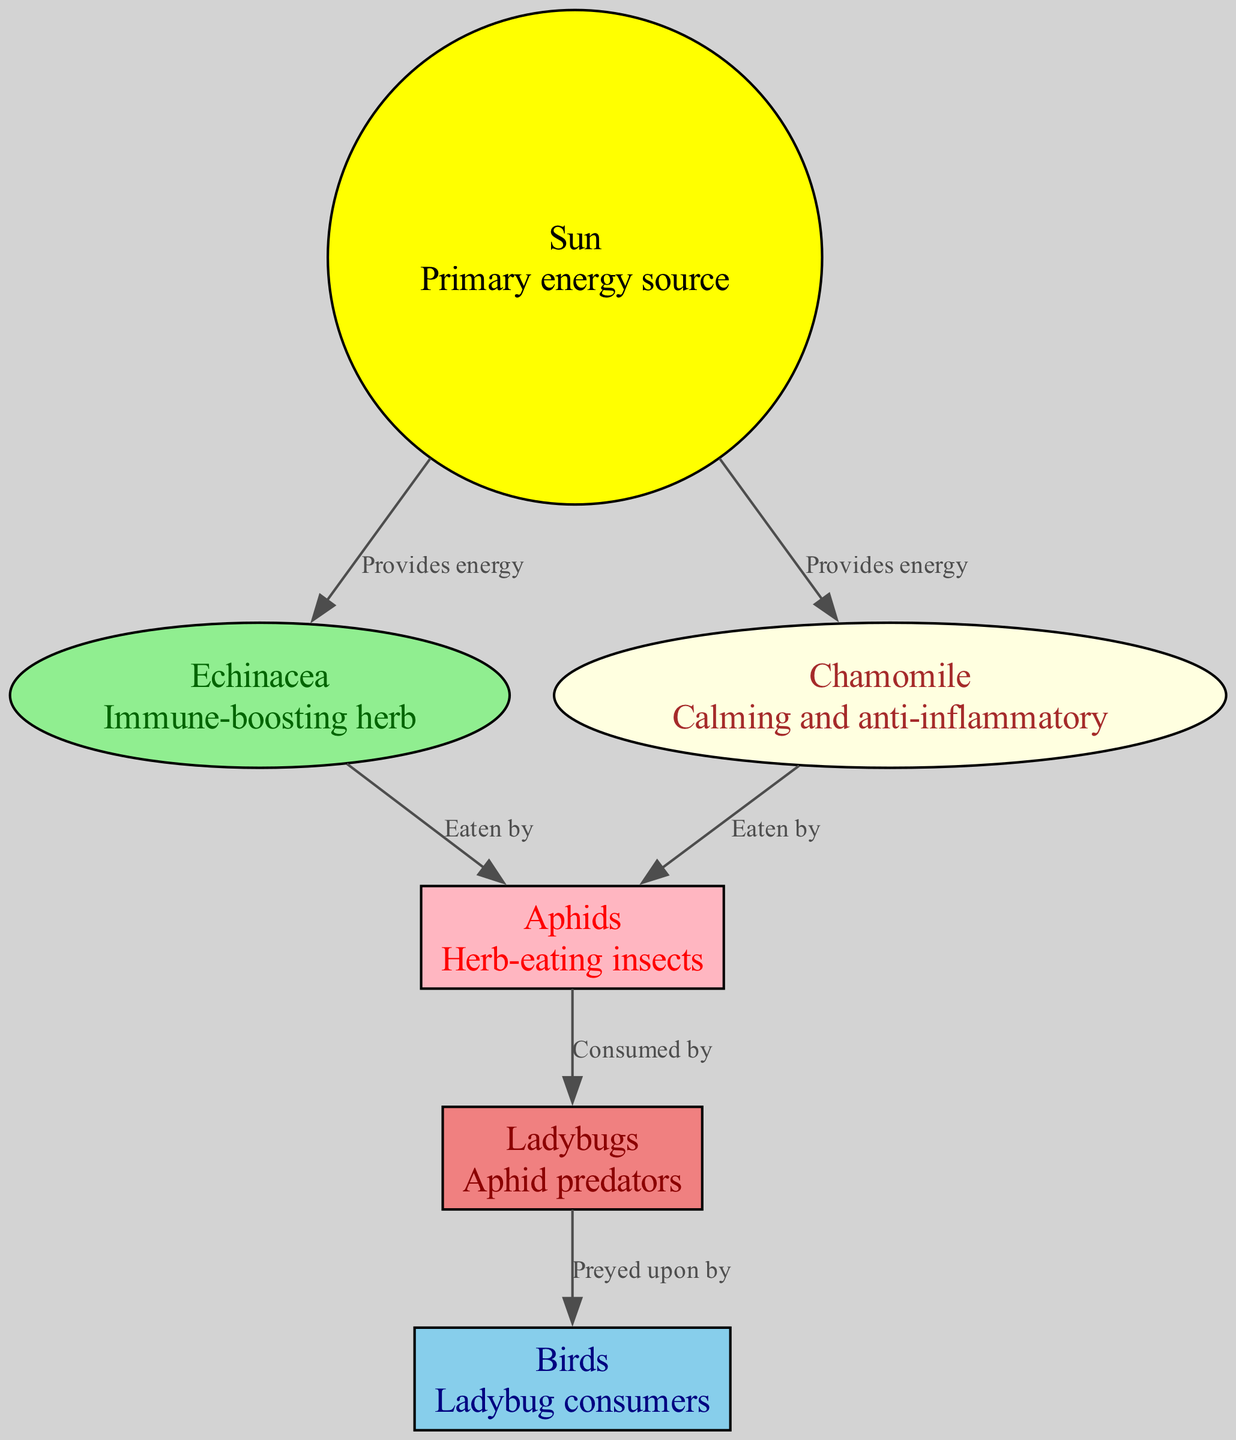What is the primary energy source in the diagram? The diagram identifies the "Sun" as the primary energy source. It is the first node, indicating its central role in the food chain.
Answer: Sun How many herb-eating insects are in the food chain? The diagram shows "Aphids" as the only herb-eating insect present in the food chain, making it count as one.
Answer: 1 Which medicinal herb is eaten by ladybugs? "Echinacea" is identified in the diagram as being eaten by ladybugs, resulting in the direct relationship displayed in the connections.
Answer: Echinacea What is the role of ladybugs in this food chain? Ladybugs are predators of aphids, as evidenced by the directed edge from "Aphids" to "Ladybugs" labeled "Consumed by," indicating their role as consumers in this food chain.
Answer: Predators How many edges are connected to the "Chamomile" node? There are two edges connected to "Chamomile" — one leading to "Aphids" (Eaten by) and another from the "Sun" (Provides energy), thus totaling to two edges connected to this node.
Answer: 2 What do birds prey upon in this food chain? According to the diagram, "Birds" are indicated to prey upon "Ladybugs," confirming their role in the food hierarchy as consumers of ladybugs.
Answer: Ladybugs What type of relationship exists between the Sun and Echinacea? The relationship is defined as "Provides energy," which signifies that the Sun's energy is essential for the growth and medicinal properties of Echinacea, shown through the directed edge.
Answer: Provides energy What color represents birds in the diagram? Birds are represented with a sky-blue fill color in the diagram, allowing viewers to easily distinguish them from other entities based on color coding.
Answer: Skyblue Which herb has calming and anti-inflammatory properties? "Chamomile" is noted in the diagram for its calming and anti-inflammatory properties, directly matching its description in the node.
Answer: Chamomile 